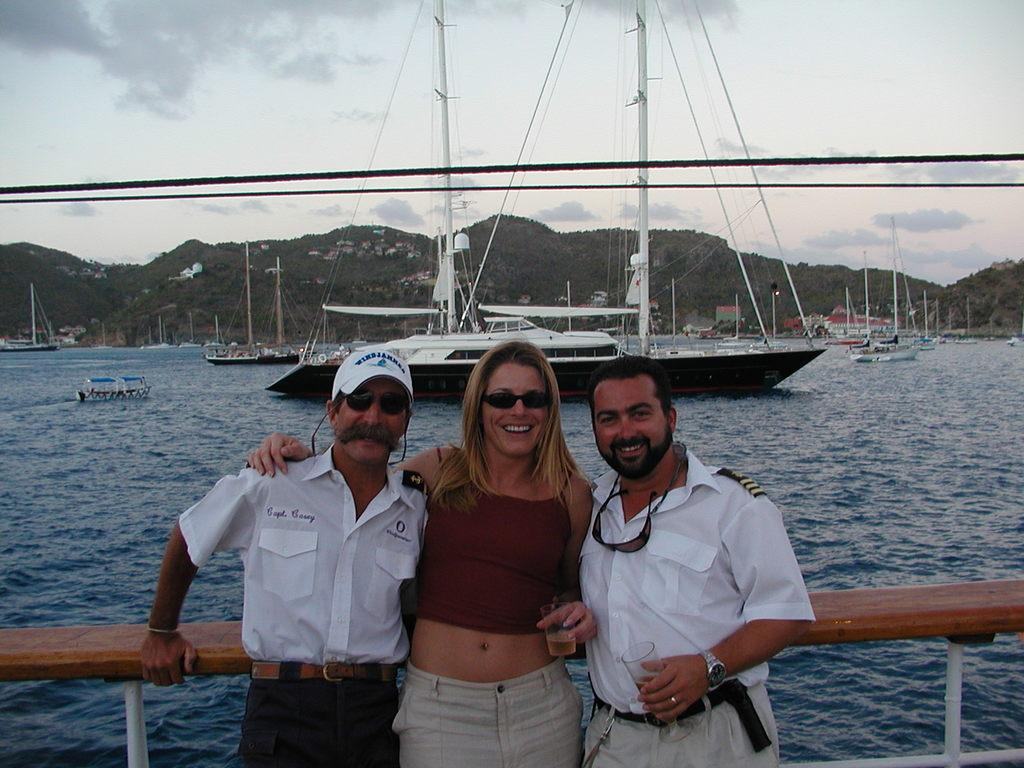What type of vehicles can be seen in the image? There are ships in the image. What is the primary element surrounding the ships? There is water visible in the image. What type of natural landform is present in the image? There are mountains in the image. Can you describe the people in the image? There are people in the image. What part of the natural environment is visible in the image? The sky is visible in the image. What type of religion is being practiced by the people in the image? There is no indication of any religious practice in the image; it features ships, water, mountains, people, and the sky. What type of cream is being used by the people in the image? There is no cream present in the image. 